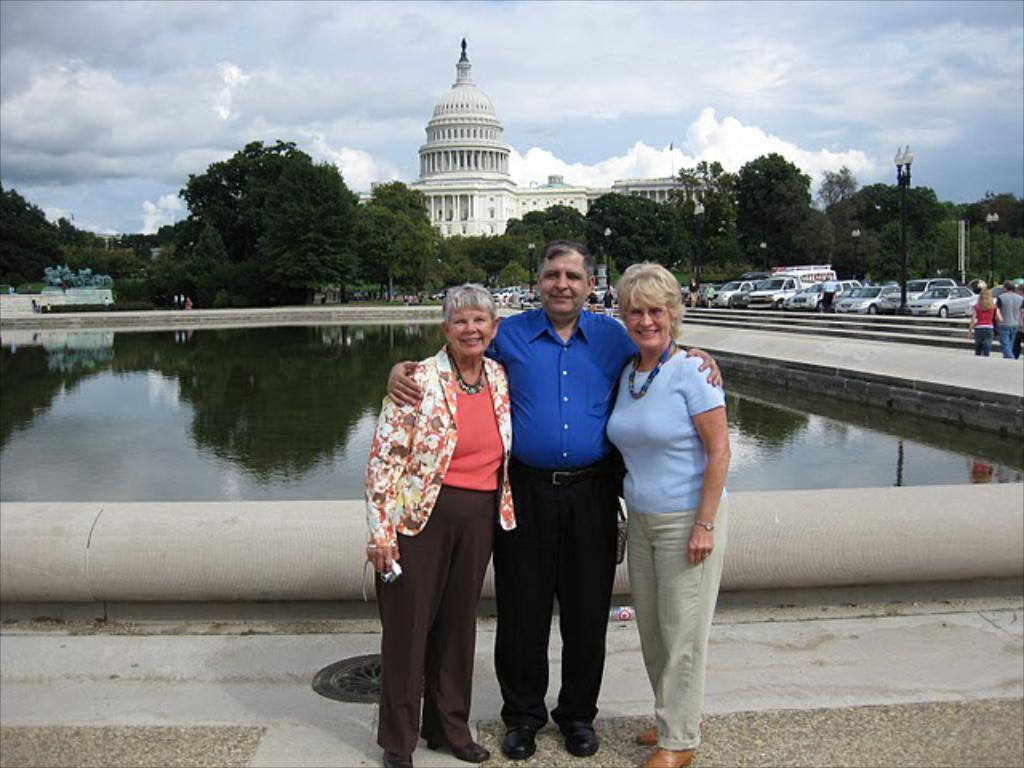Could you give a brief overview of what you see in this image? In this picture we can see a man and two women are standing in the front, on the right side there are some vehicles and two persons, there is water in the middle, in the background we can see trees, a building, poles and lights, we can see the sky at the top of the picture. 